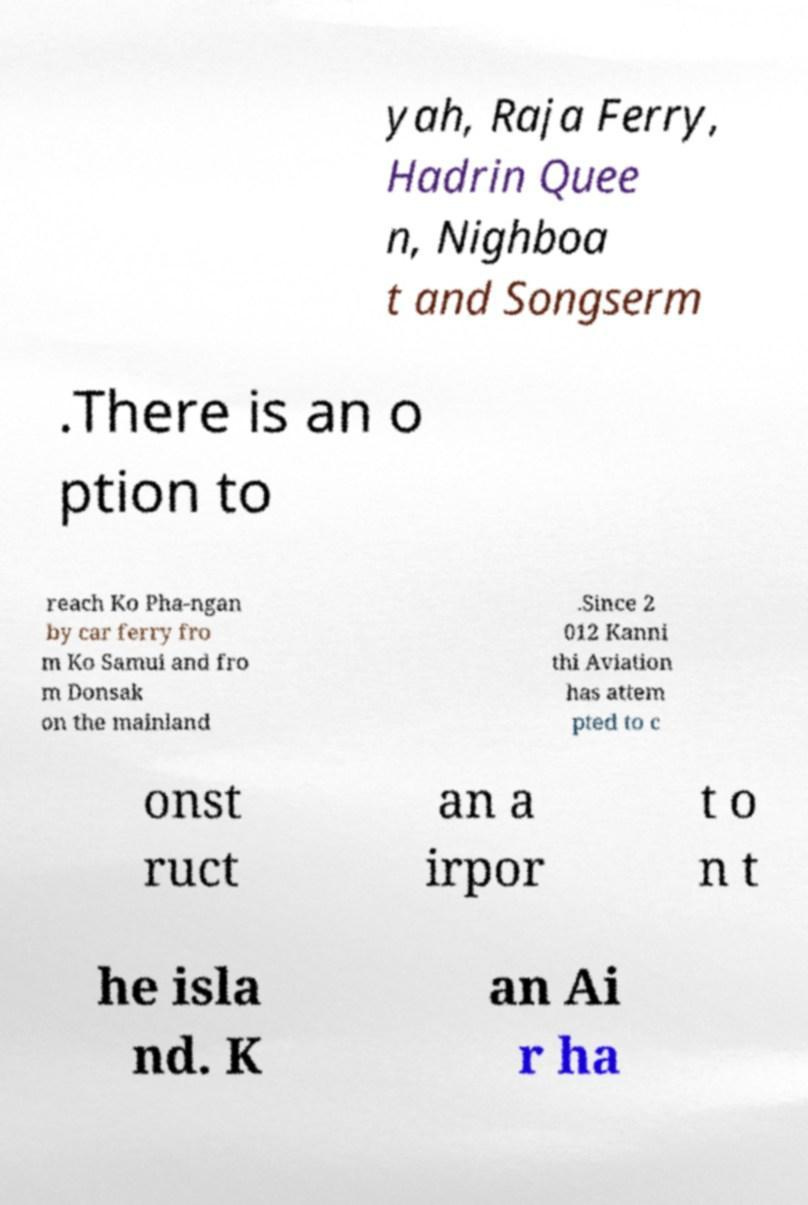Please read and relay the text visible in this image. What does it say? yah, Raja Ferry, Hadrin Quee n, Nighboa t and Songserm .There is an o ption to reach Ko Pha-ngan by car ferry fro m Ko Samui and fro m Donsak on the mainland .Since 2 012 Kanni thi Aviation has attem pted to c onst ruct an a irpor t o n t he isla nd. K an Ai r ha 